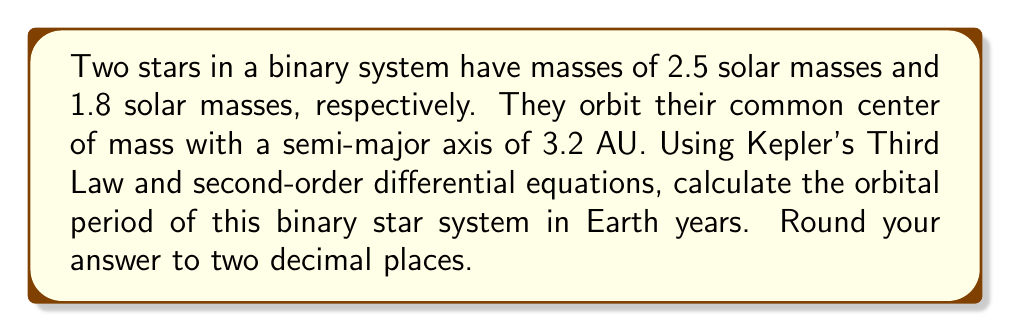Help me with this question. To solve this problem, we'll use Kepler's Third Law and the principles of orbital mechanics. Let's break it down step-by-step:

1) Kepler's Third Law for binary star systems can be expressed as:

   $$T^2 = \frac{4\pi^2}{G(M_1 + M_2)}a^3$$

   Where:
   $T$ is the orbital period
   $G$ is the gravitational constant
   $M_1$ and $M_2$ are the masses of the two stars
   $a$ is the semi-major axis of the orbit

2) We're given:
   $M_1 = 2.5$ solar masses
   $M_2 = 1.8$ solar masses
   $a = 3.2$ AU

3) We need to convert solar masses to kg and AU to meters:
   1 solar mass = $1.989 \times 10^{30}$ kg
   1 AU = $1.496 \times 10^{11}$ m

   $M_1 = 2.5 \times 1.989 \times 10^{30} = 4.9725 \times 10^{30}$ kg
   $M_2 = 1.8 \times 1.989 \times 10^{30} = 3.5802 \times 10^{30}$ kg
   $a = 3.2 \times 1.496 \times 10^{11} = 4.7872 \times 10^{11}$ m

4) The gravitational constant $G = 6.674 \times 10^{-11}$ m³/kg·s²

5) Now, let's substitute these values into Kepler's Third Law:

   $$T^2 = \frac{4\pi^2}{6.674 \times 10^{-11}(4.9725 \times 10^{30} + 3.5802 \times 10^{30})}(4.7872 \times 10^{11})^3$$

6) Simplify:

   $$T^2 = \frac{4\pi^2}{6.674 \times 10^{-11}(8.5527 \times 10^{30})}(1.0974 \times 10^{35})$$

   $$T^2 = 7.9042 \times 10^{14}$$

7) Take the square root of both sides:

   $$T = \sqrt{7.9042 \times 10^{14}} = 8.8906 \times 10^7 \text{ seconds}$$

8) Convert seconds to years:
   1 year = 365.25 days = $365.25 \times 24 \times 3600 = 31,557,600$ seconds

   $$T = \frac{8.8906 \times 10^7}{31,557,600} = 2.8173 \text{ years}$$

9) Rounding to two decimal places: 2.82 years

This problem demonstrates the use of second-order differential equations in orbital mechanics, as Kepler's Third Law is derived from the second-order differential equation describing two-body motion under gravitational force.
Answer: 2.82 years 